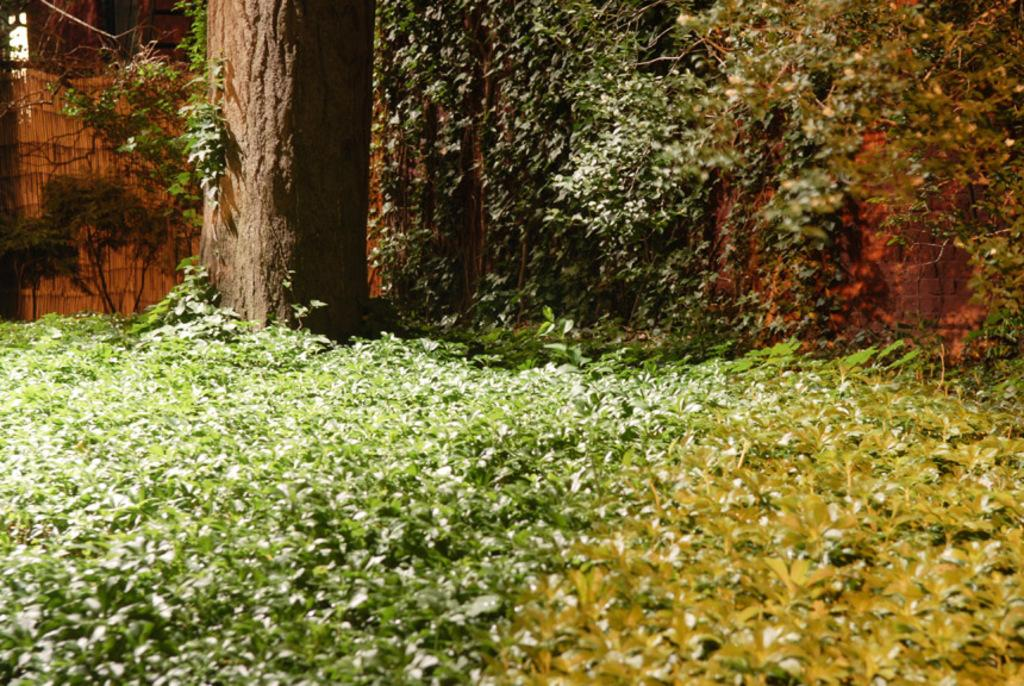What type of living organisms can be seen in the image? Plants can be seen in the image. Can you describe a specific part of a plant in the image? There is a branch of a tree on the left side of the image. Where is the faucet located in the image? There is no faucet present in the image. 